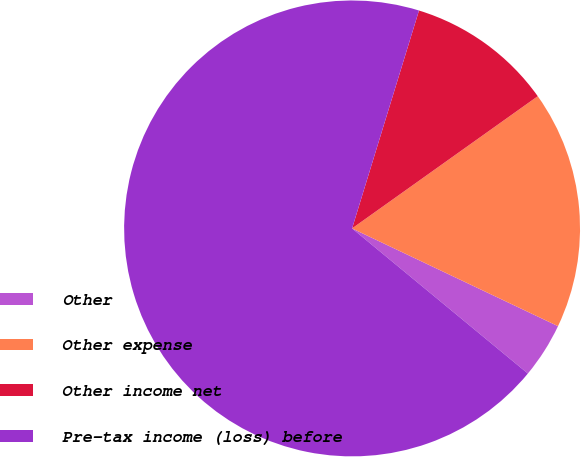<chart> <loc_0><loc_0><loc_500><loc_500><pie_chart><fcel>Other<fcel>Other expense<fcel>Other income net<fcel>Pre-tax income (loss) before<nl><fcel>3.93%<fcel>16.9%<fcel>10.41%<fcel>68.76%<nl></chart> 